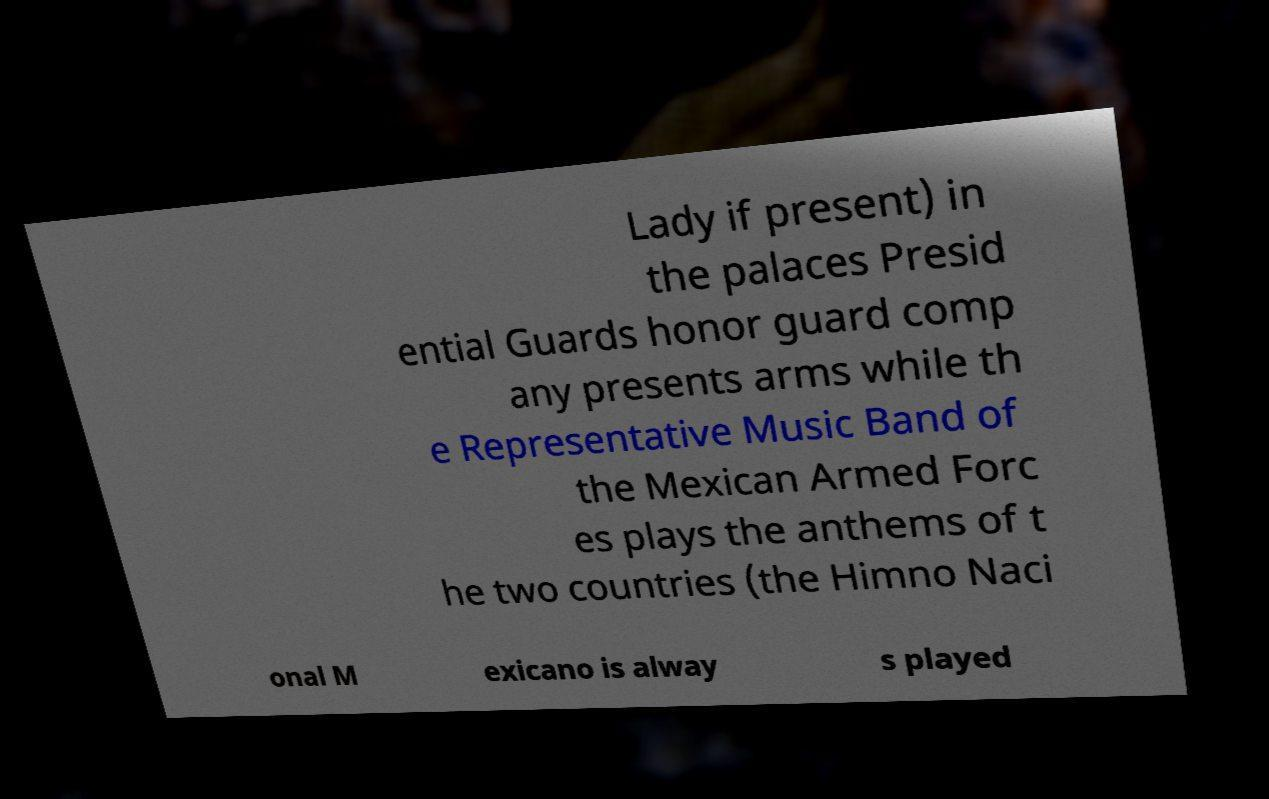Can you read and provide the text displayed in the image?This photo seems to have some interesting text. Can you extract and type it out for me? Lady if present) in the palaces Presid ential Guards honor guard comp any presents arms while th e Representative Music Band of the Mexican Armed Forc es plays the anthems of t he two countries (the Himno Naci onal M exicano is alway s played 